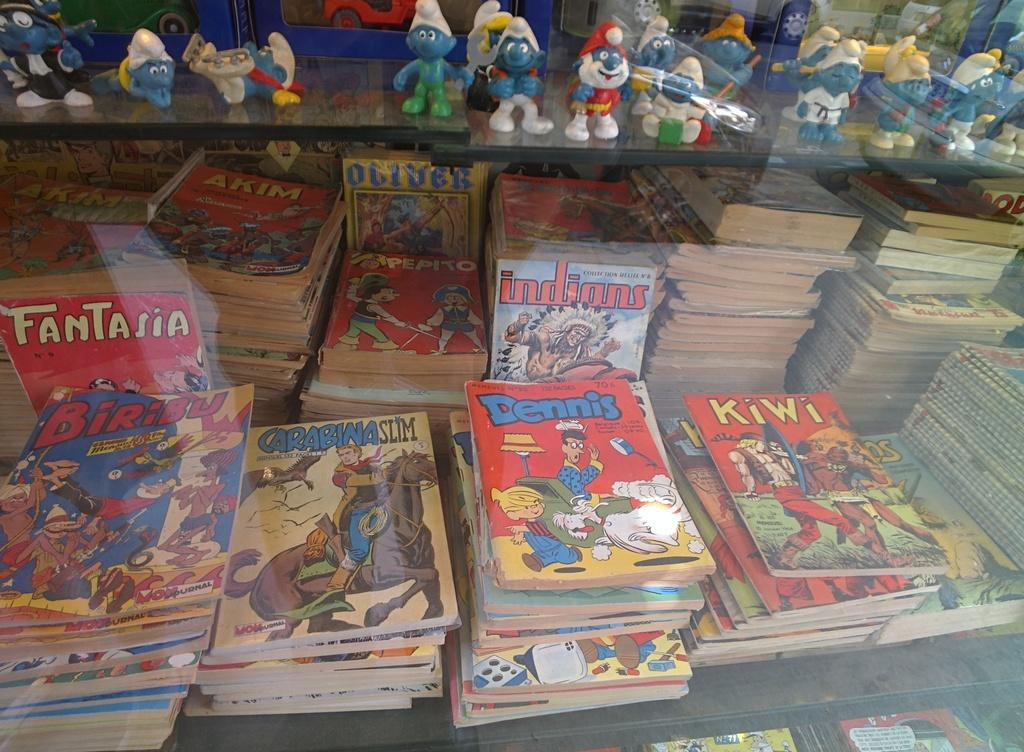Provide a one-sentence caption for the provided image. I collection of old comic books, including Fantasia and Dennis the Menace. 